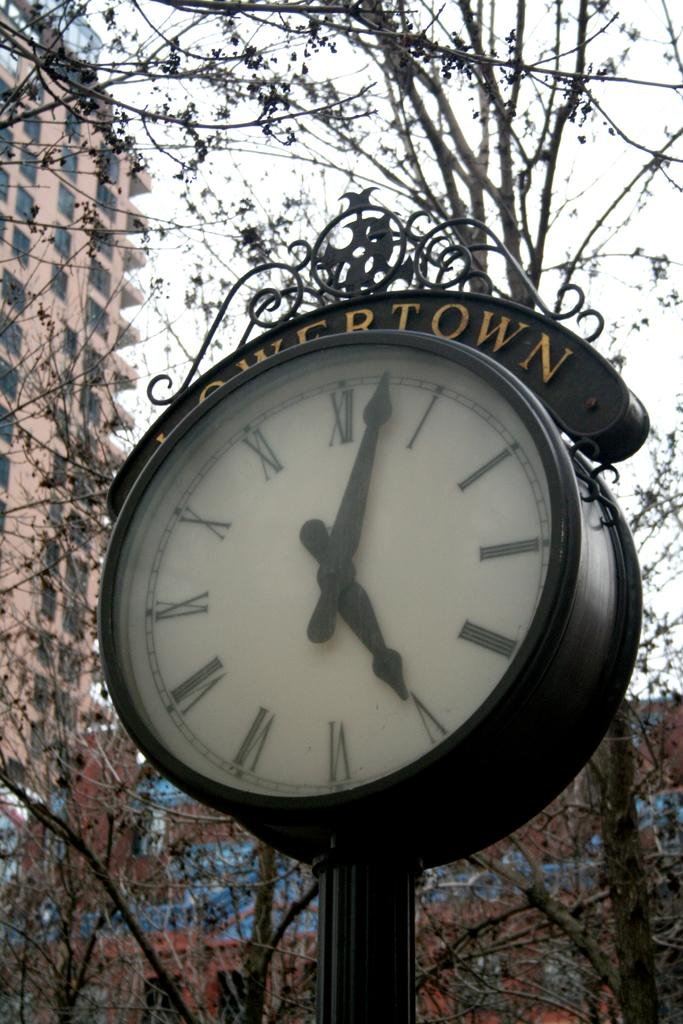<image>
Share a concise interpretation of the image provided. Circular clock outside of a building and says LOWERTOWN on it. 